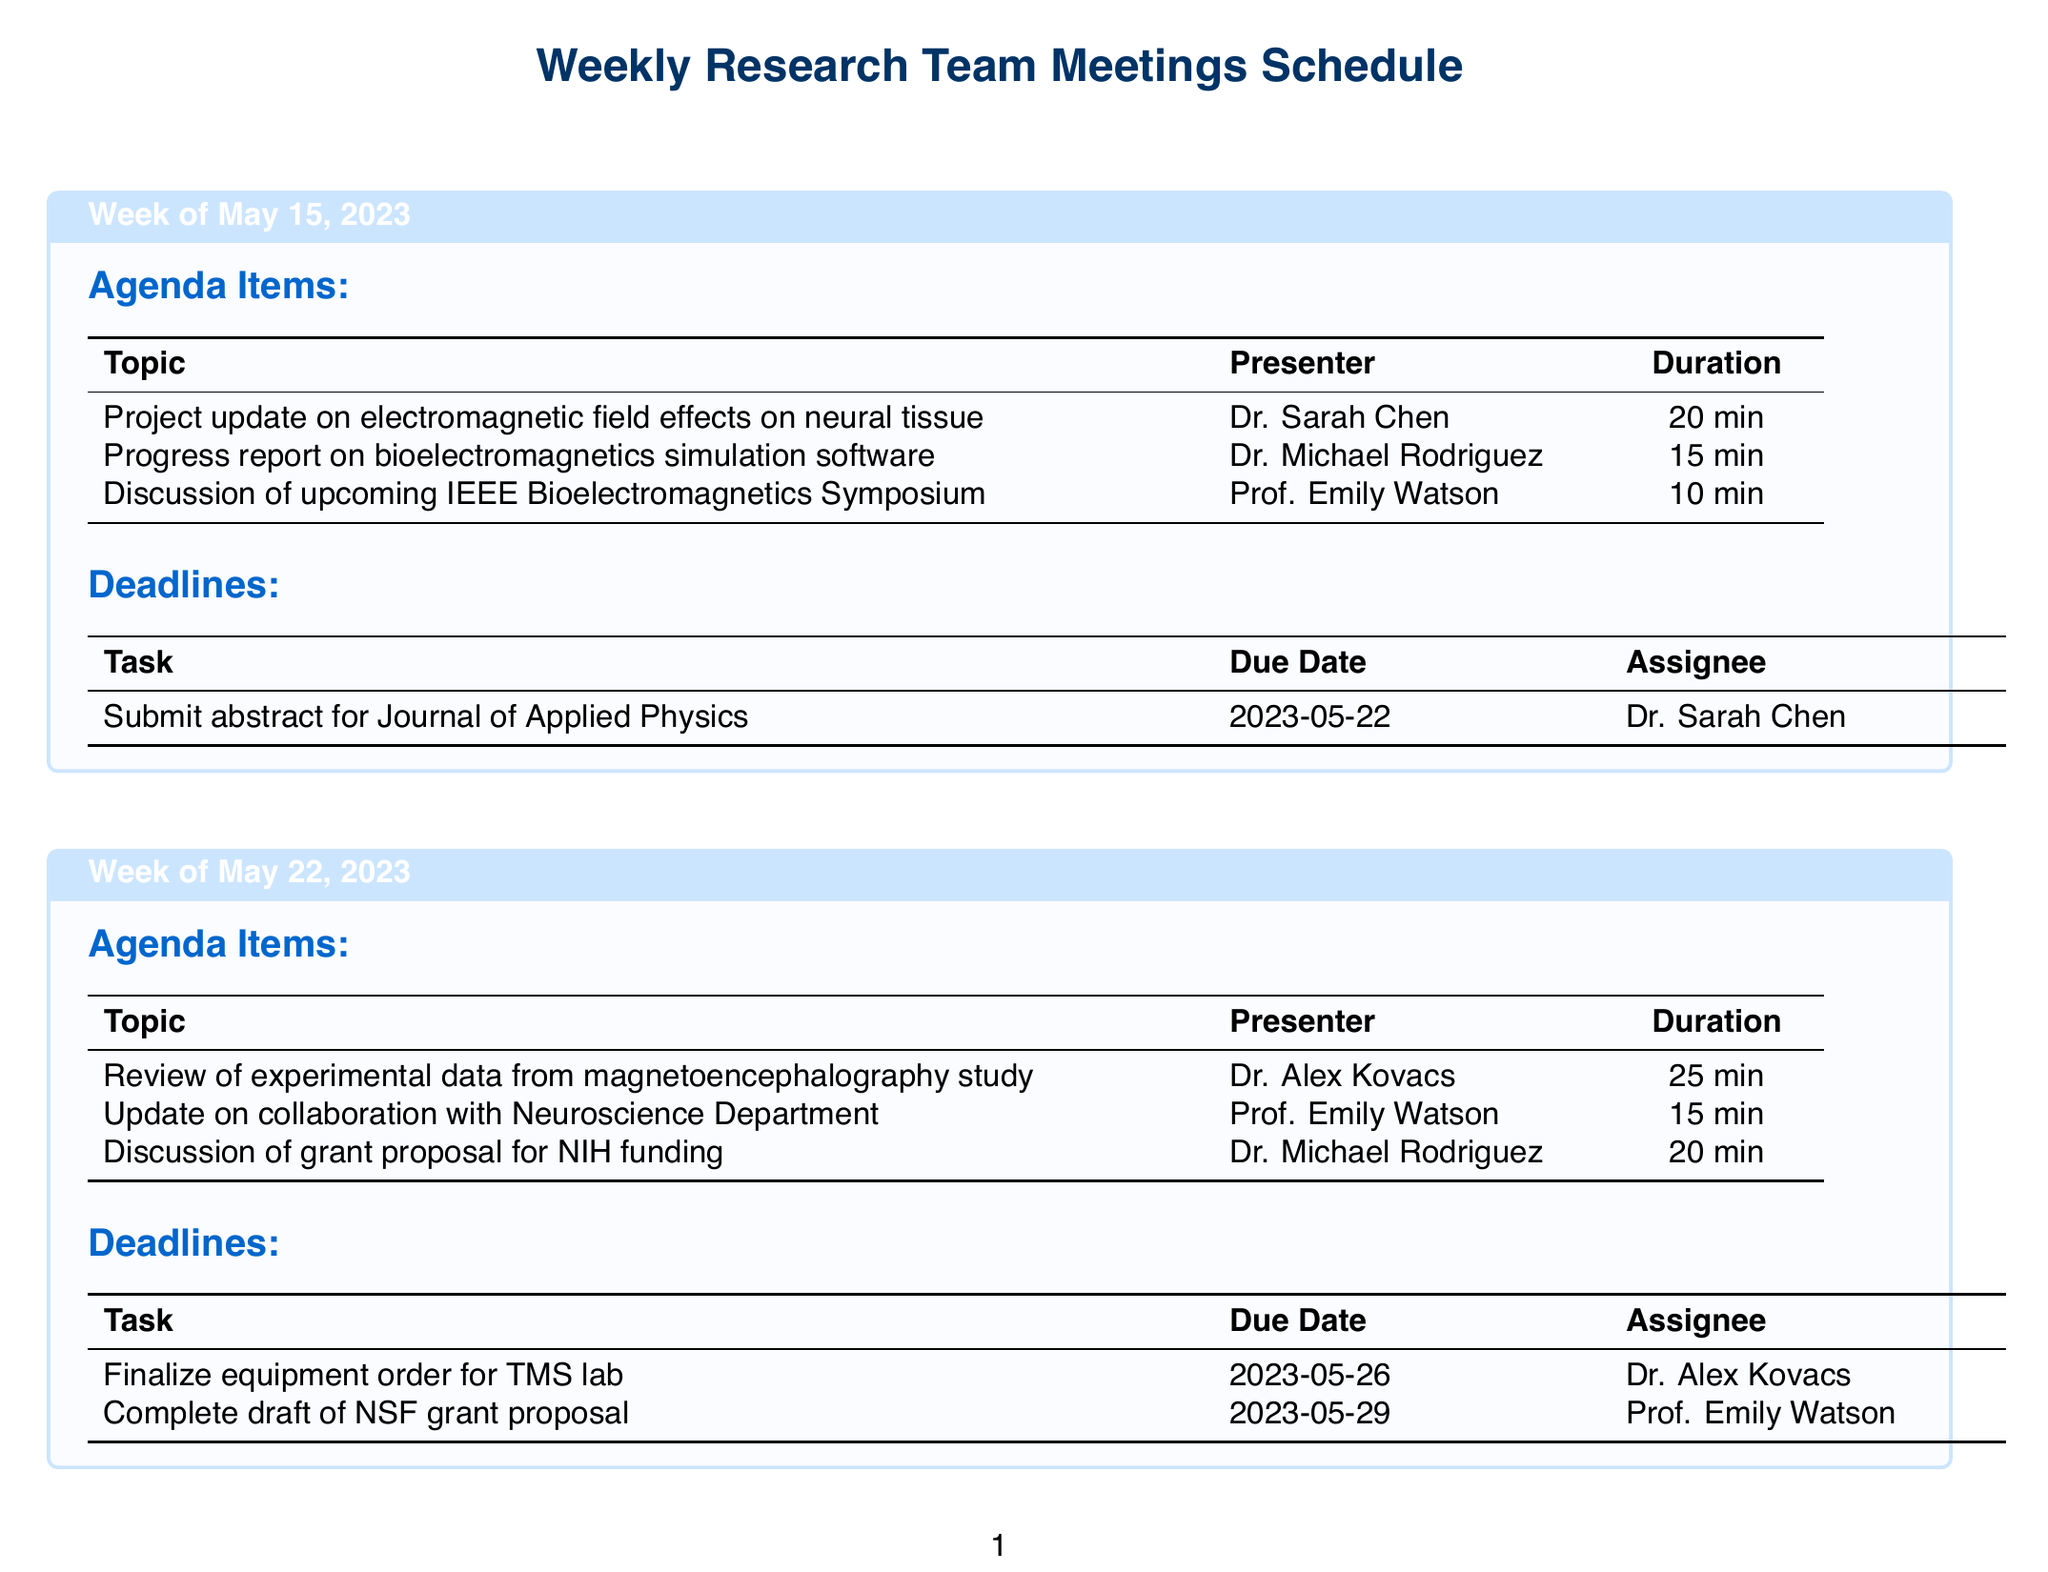What is the date of the first meeting? The first meeting is scheduled for May 15, 2023.
Answer: May 15, 2023 Who presented the update on manuscript preparation for Nature Biomedical Engineering? Dr. Sarah Chen presented the update on manuscript preparation for Nature Biomedical Engineering.
Answer: Dr. Sarah Chen What is the duration of the presentation on new findings in transcranial magnetic stimulation? The presentation by Dr. Sarah Chen lasts for 30 minutes.
Answer: 30 minutes What task is due on June 9, 2023? The task due on June 9, 2023, is to submit an abstract for the International Conference on Bioelectromagnetism.
Answer: Submit abstract for International Conference on Bioelectromagnetism Which week has a discussion regarding a potential collaboration with Stanford University? The discussion about collaboration with Stanford University is in the week of May 29, 2023.
Answer: Week of May 29, 2023 How many minutes is allocated for the discussion on the upcoming visit from DARPA? The discussion on the upcoming visit from DARPA program manager is allocated 20 minutes.
Answer: 20 minutes Who is responsible for finalizing the equipment order for the TMS lab? Dr. Alex Kovacs is responsible for finalizing the equipment order for the TMS lab.
Answer: Dr. Alex Kovacs What is the last deadline listed in the schedule? The last deadline listed is June 12, 2023, for completing safety protocol updates for lab experiments.
Answer: June 12, 2023 Which presenter covered the progress report on bioelectromagnetics simulation software? The progress report on bioelectromagnetics simulation software was covered by Dr. Michael Rodriguez.
Answer: Dr. Michael Rodriguez 